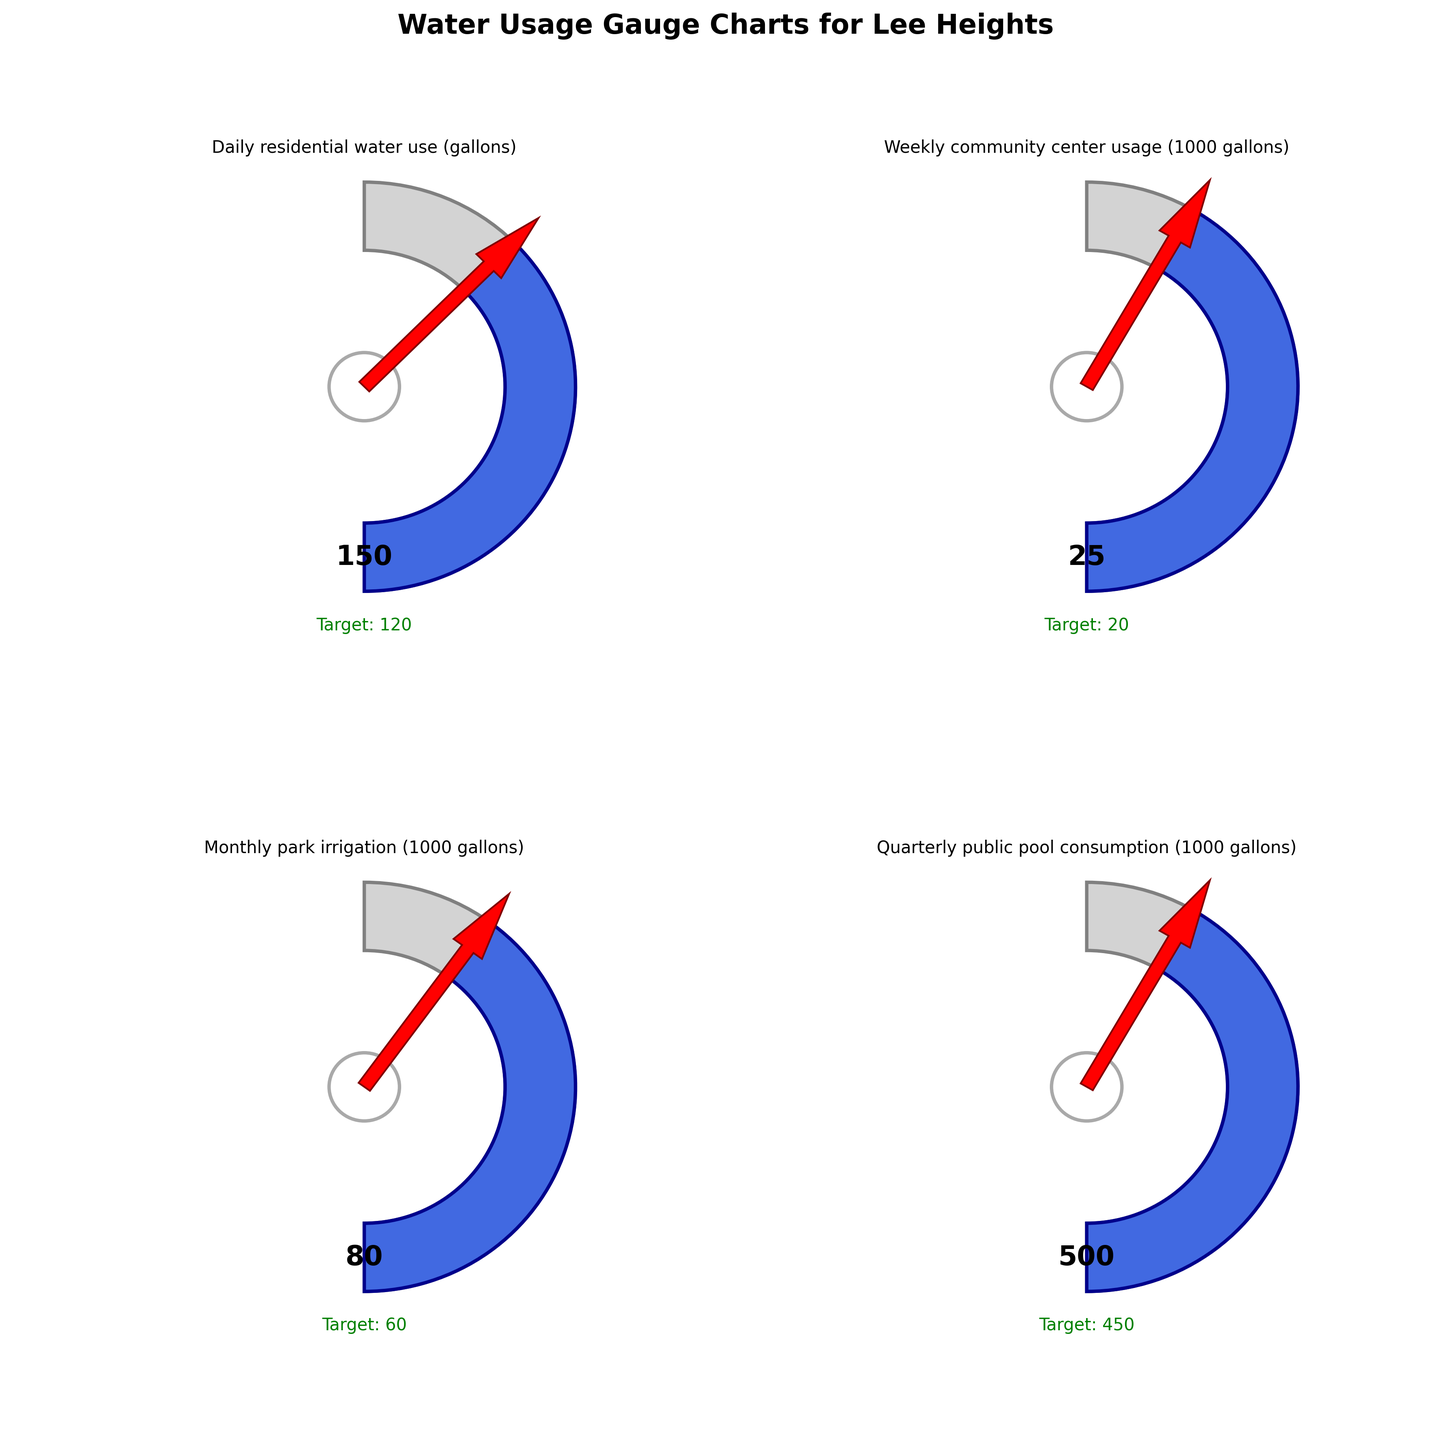What's the title of the figure? The title of the figure is written at the top of the image in bold letters. It reads "Water Usage Gauge Charts for Lee Heights".
Answer: Water Usage Gauge Charts for Lee Heights How much higher is the current daily residential water use compared to the target usage? To answer this, subtract the target usage (120 gallons) from the current usage (150 gallons). 150 - 120 = 30 gallons.
Answer: 30 gallons Which category shows the highest target usage? Look at the target usage values for each category. The "Quarterly public pool consumption" has the highest target usage of 450, which is higher than the other categories.
Answer: Quarterly public pool consumption Has the monthly park irrigation met its target usage? Compare the current usage (80,000 gallons) with the target usage (60,000 gallons). Since 80,000 is greater than 60,000, it has not met its target.
Answer: No What is the sum of the target usages across all categories? Add up the target usages for all categories: 
120 (daily) + 20 (weekly) + 60 (monthly) + 450 (quarterly) = 650 gallons (in thousands for weekly, monthly, and quarterly).
Answer: 650 gallons In which direction does the arrow point for the "Weekly community center usage"? The arrow points to show the current usage on the gauge. In "Weekly community center usage," it points toward the high end within the blue area, somewhat close to the maximum value.
Answer: Toward the higher end What's the overall range of current usage values across all categories? Find the minimum and maximum values of the current usage:
Minimum: 25 (Weekly community center usage)
Maximum: 500 (Quarterly public pool consumption)
The range is 500 - 25 = 475.
Answer: 475 